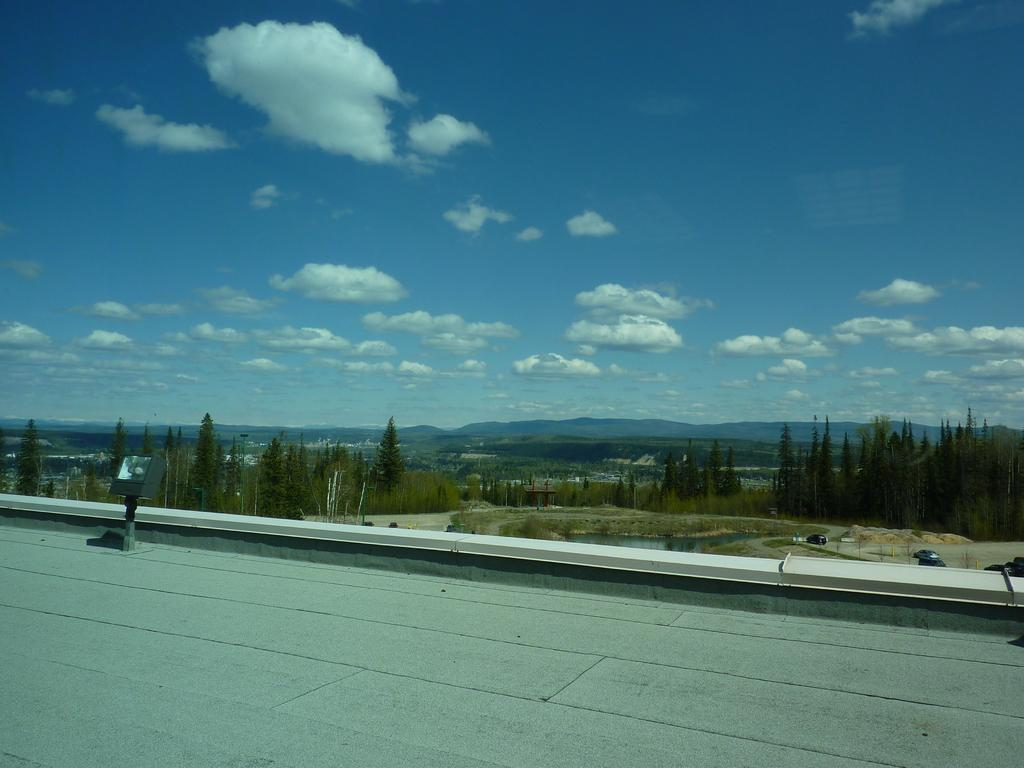What is located in the center of the image? There are buildings and trees in the center of the image. Can you describe the sky in the image? The sky is visible at the top side of the image. What country is the person saying good-bye to in the image? There is no person or good-bye in the image; it only features buildings, trees, and the sky. 